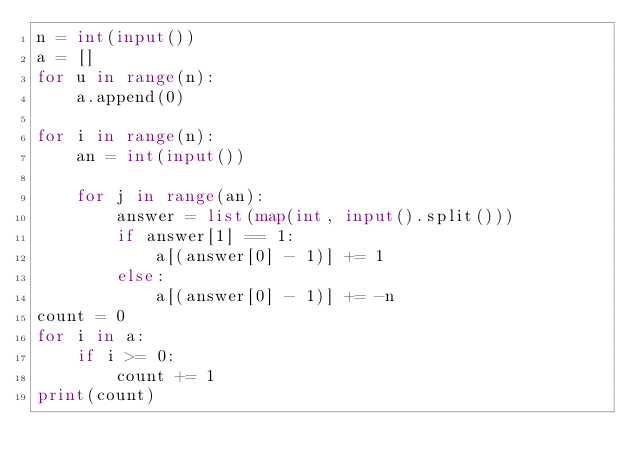Convert code to text. <code><loc_0><loc_0><loc_500><loc_500><_Python_>n = int(input())
a = []
for u in range(n):
    a.append(0)

for i in range(n):
    an = int(input())

    for j in range(an):
        answer = list(map(int, input().split()))
        if answer[1] == 1:
            a[(answer[0] - 1)] += 1
        else:
            a[(answer[0] - 1)] += -n
count = 0
for i in a:
    if i >= 0:
        count += 1
print(count)
        </code> 